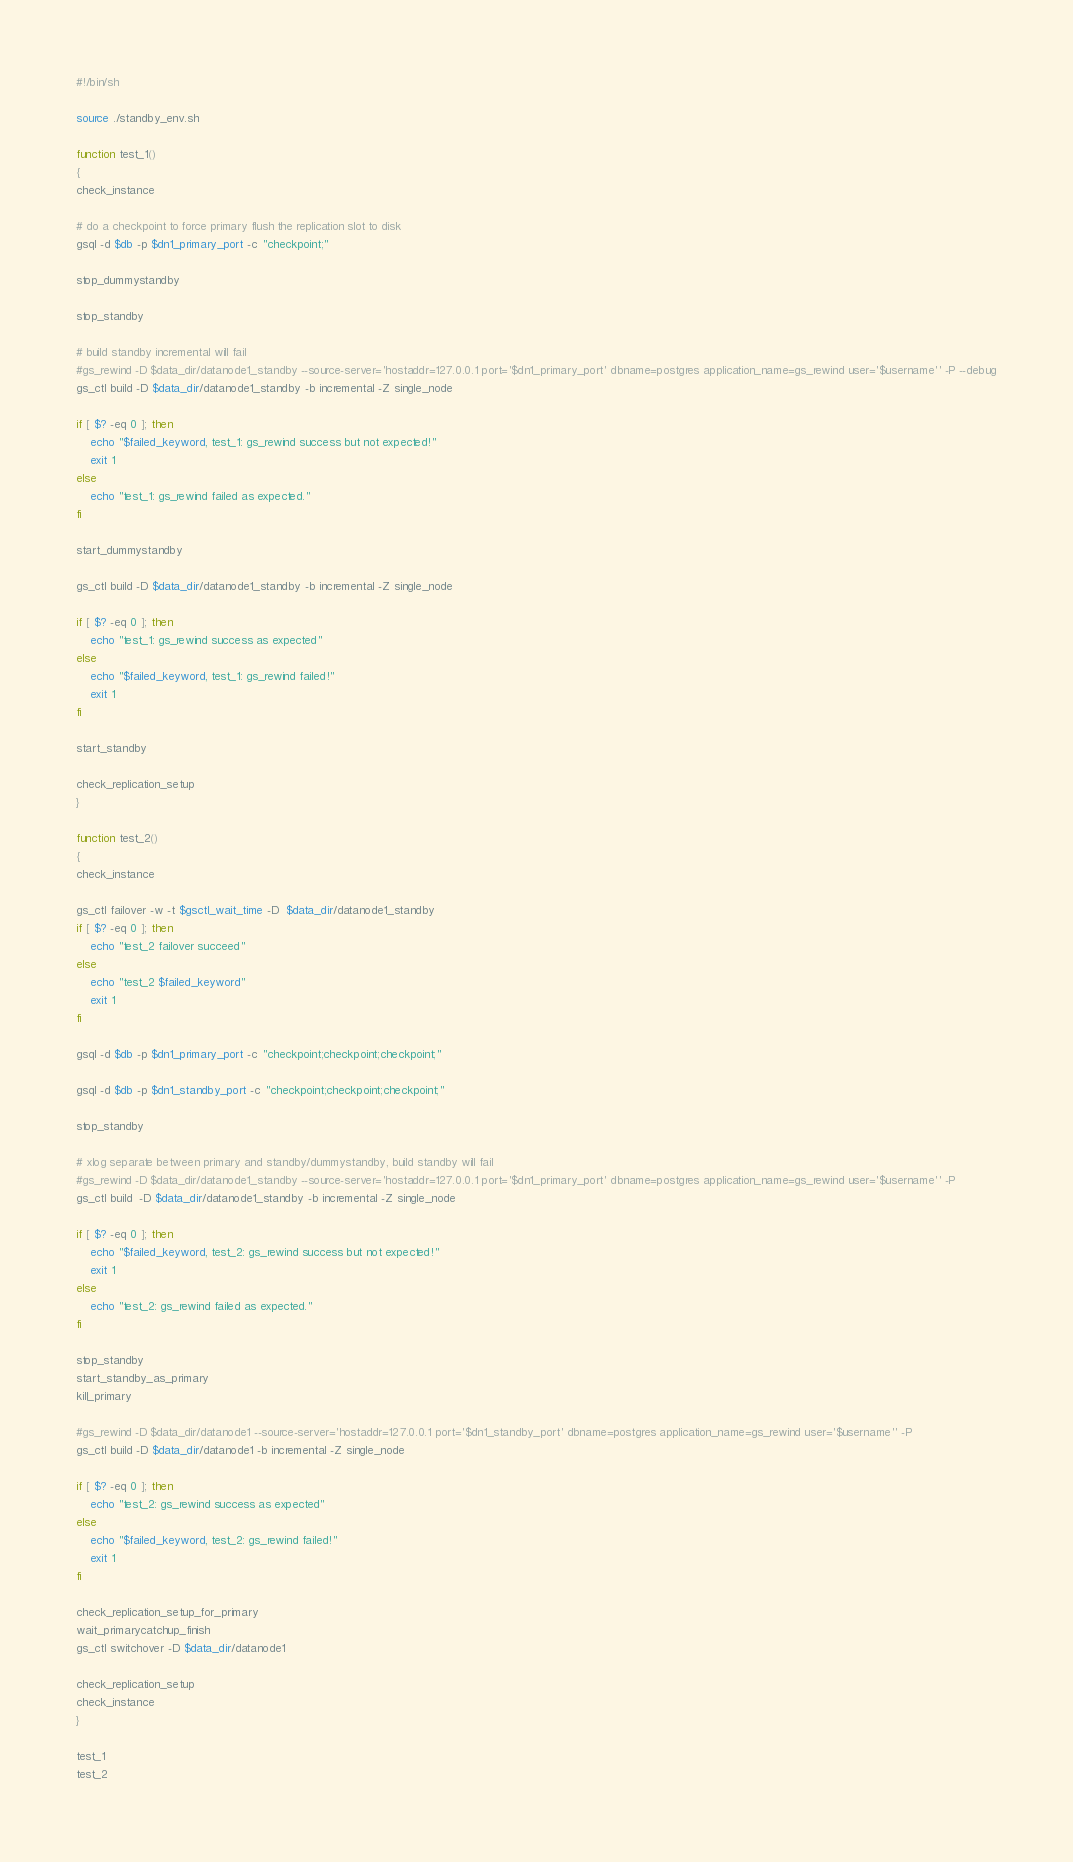<code> <loc_0><loc_0><loc_500><loc_500><_Bash_>#!/bin/sh

source ./standby_env.sh

function test_1()
{
check_instance

# do a checkpoint to force primary flush the replication slot to disk
gsql -d $db -p $dn1_primary_port -c "checkpoint;"

stop_dummystandby

stop_standby

# build standby incremental will fail
#gs_rewind -D $data_dir/datanode1_standby --source-server='hostaddr=127.0.0.1 port='$dn1_primary_port' dbname=postgres application_name=gs_rewind user='$username'' -P --debug
gs_ctl build -D $data_dir/datanode1_standby -b incremental -Z single_node

if [ $? -eq 0 ]; then
	echo "$failed_keyword, test_1: gs_rewind success but not expected!"
	exit 1
else
	echo "test_1: gs_rewind failed as expected."
fi

start_dummystandby

gs_ctl build -D $data_dir/datanode1_standby -b incremental -Z single_node 

if [ $? -eq 0 ]; then
	echo "test_1: gs_rewind success as expected"
else
	echo "$failed_keyword, test_1: gs_rewind failed!"
	exit 1
fi

start_standby

check_replication_setup
}

function test_2()
{
check_instance

gs_ctl failover -w -t $gsctl_wait_time -D  $data_dir/datanode1_standby
if [ $? -eq 0 ]; then
    echo "test_2 failover succeed"
else
	echo "test_2 $failed_keyword"
	exit 1
fi

gsql -d $db -p $dn1_primary_port -c "checkpoint;checkpoint;checkpoint;"

gsql -d $db -p $dn1_standby_port -c "checkpoint;checkpoint;checkpoint;"

stop_standby

# xlog separate between primary and standby/dummystandby, build standby will fail
#gs_rewind -D $data_dir/datanode1_standby --source-server='hostaddr=127.0.0.1 port='$dn1_primary_port' dbname=postgres application_name=gs_rewind user='$username'' -P
gs_ctl build  -D $data_dir/datanode1_standby -b incremental -Z single_node

if [ $? -eq 0 ]; then
	echo "$failed_keyword, test_2: gs_rewind success but not expected!"
	exit 1
else
	echo "test_2: gs_rewind failed as expected."
fi

stop_standby
start_standby_as_primary
kill_primary

#gs_rewind -D $data_dir/datanode1 --source-server='hostaddr=127.0.0.1 port='$dn1_standby_port' dbname=postgres application_name=gs_rewind user='$username'' -P
gs_ctl build -D $data_dir/datanode1 -b incremental -Z single_node

if [ $? -eq 0 ]; then
	echo "test_2: gs_rewind success as expected"
else
	echo "$failed_keyword, test_2: gs_rewind failed!"
	exit 1
fi

check_replication_setup_for_primary
wait_primarycatchup_finish
gs_ctl switchover -D $data_dir/datanode1

check_replication_setup
check_instance
}

test_1
test_2

</code> 